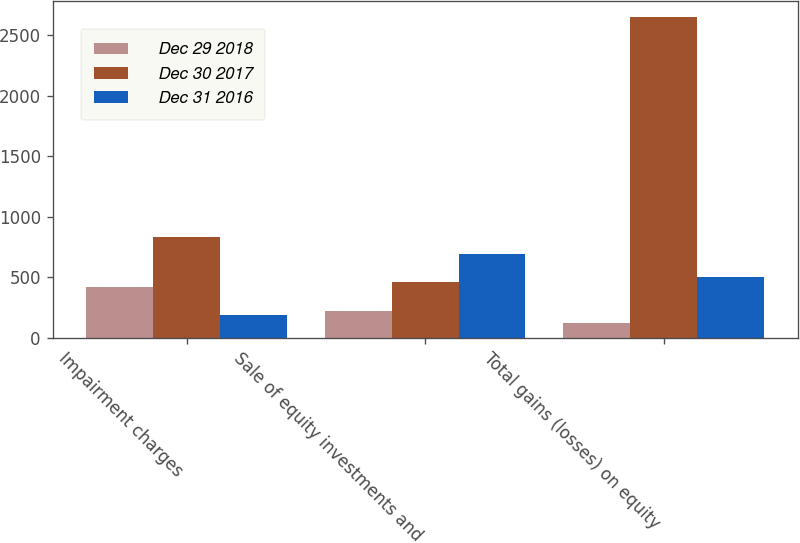Convert chart. <chart><loc_0><loc_0><loc_500><loc_500><stacked_bar_chart><ecel><fcel>Impairment charges<fcel>Sale of equity investments and<fcel>Total gains (losses) on equity<nl><fcel>Dec 29 2018<fcel>424<fcel>226<fcel>125<nl><fcel>Dec 30 2017<fcel>833<fcel>465<fcel>2651<nl><fcel>Dec 31 2016<fcel>187<fcel>693<fcel>506<nl></chart> 